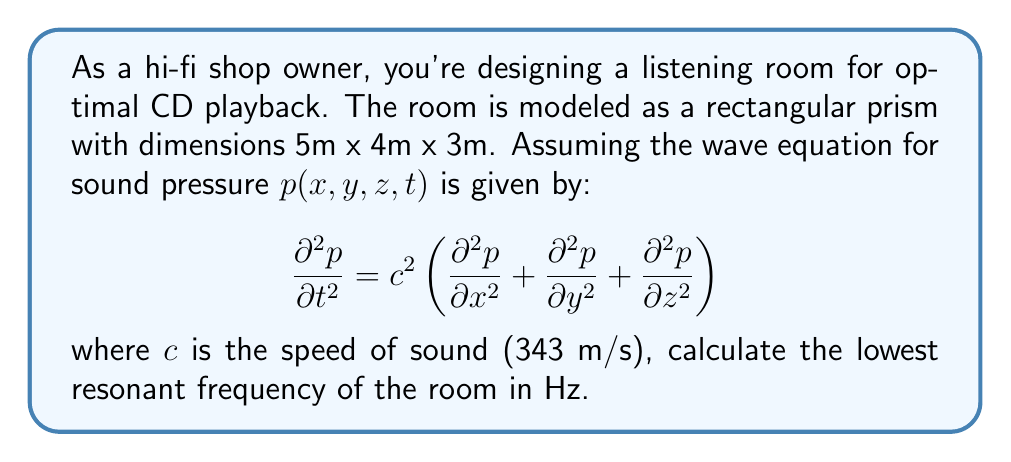Solve this math problem. To solve this problem, we need to follow these steps:

1) The general solution for the wave equation in a rectangular room is:

   $$p(x,y,z,t) = \cos(\omega t) \cos(k_x x) \cos(k_y y) \cos(k_z z)$$

2) The wavenumbers $k_x$, $k_y$, and $k_z$ are related to the room dimensions:

   $$k_x = \frac{n_x \pi}{L_x}, k_y = \frac{n_y \pi}{L_y}, k_z = \frac{n_z \pi}{L_z}$$

   where $n_x$, $n_y$, and $n_z$ are non-negative integers, and $L_x$, $L_y$, and $L_z$ are the room dimensions.

3) The angular frequency $\omega$ is related to these wavenumbers:

   $$\omega^2 = c^2(k_x^2 + k_y^2 + k_z^2)$$

4) Substituting the expressions for $k_x$, $k_y$, and $k_z$:

   $$\omega^2 = c^2\pi^2\left(\frac{n_x^2}{L_x^2} + \frac{n_y^2}{L_y^2} + \frac{n_z^2}{L_z^2}\right)$$

5) The lowest resonant frequency occurs when $n_x = 1$, $n_y = 0$, and $n_z = 0$. Substituting these values and the room dimensions:

   $$\omega^2 = (343 \text{ m/s})^2 \pi^2 \left(\frac{1^2}{(5 \text{ m})^2} + \frac{0^2}{(4 \text{ m})^2} + \frac{0^2}{(3 \text{ m})^2}\right)$$

6) Simplifying:

   $$\omega^2 = 117649 \pi^2 \left(\frac{1}{25}\right) = 4705.96 \pi^2$$

7) Taking the square root:

   $$\omega = 68.60 \text{ rad/s}$$

8) Converting to frequency in Hz:

   $$f = \frac{\omega}{2\pi} = \frac{68.60}{2\pi} = 10.91 \text{ Hz}$$
Answer: 10.91 Hz 